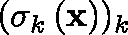Convert formula to latex. <formula><loc_0><loc_0><loc_500><loc_500>( \sigma _ { k } \left ( x \right ) ) _ { k }</formula> 